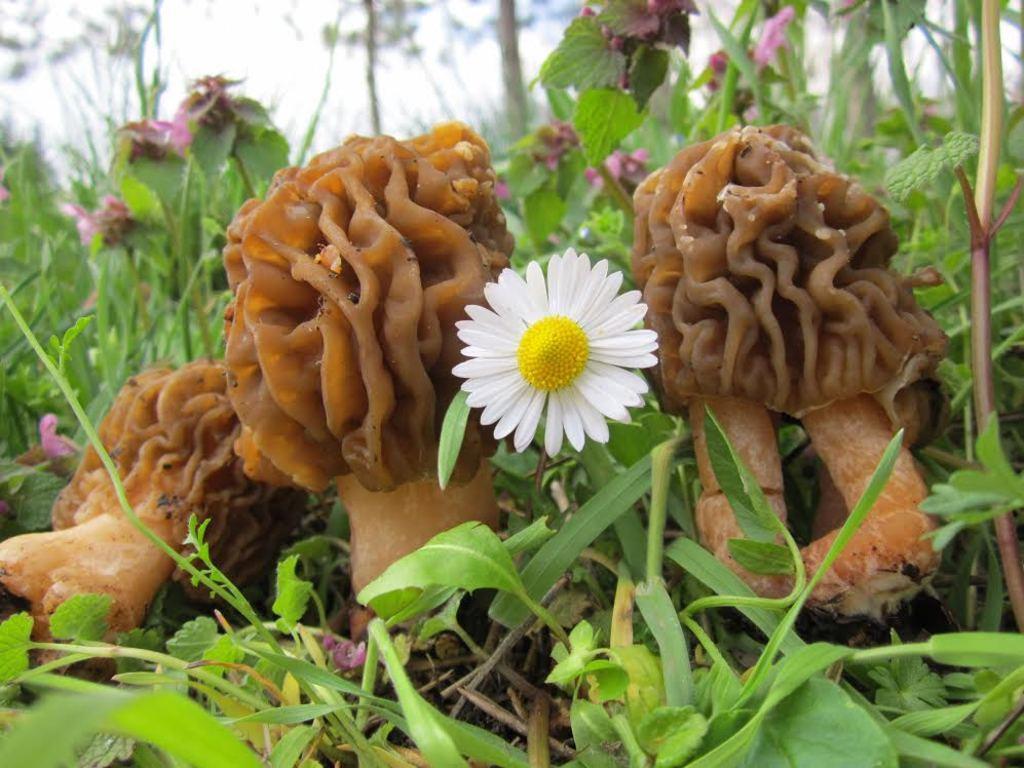Describe this image in one or two sentences. In this image there are plants truncated towards the bottom of the image, there are plants truncated towards the right of the image, there are plants truncated towards the top of the image, there are plants truncated towards the left of the image, there are objects on the ground, there is a flower, there is the sky truncated towards the top of the image. 